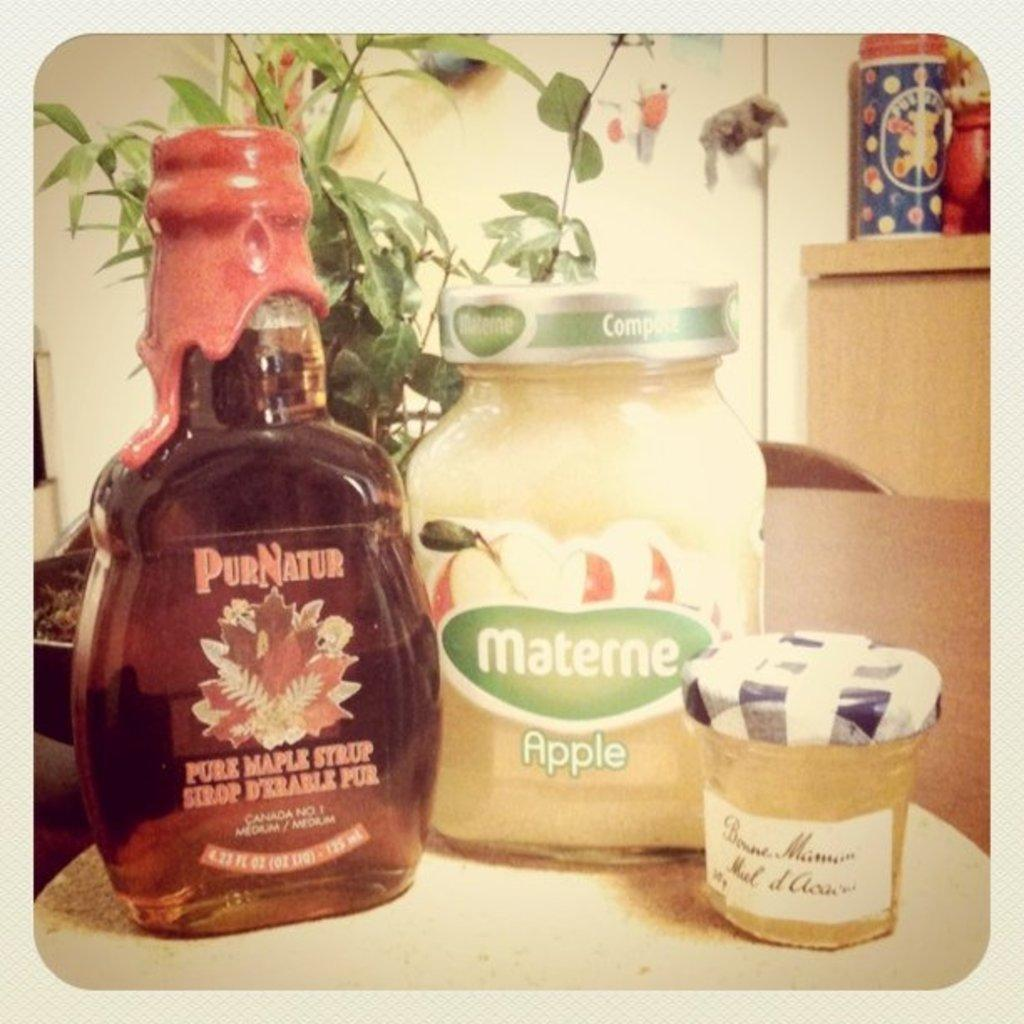Provide a one-sentence caption for the provided image. A bottle of PurNatur maple syrup is on a table. 